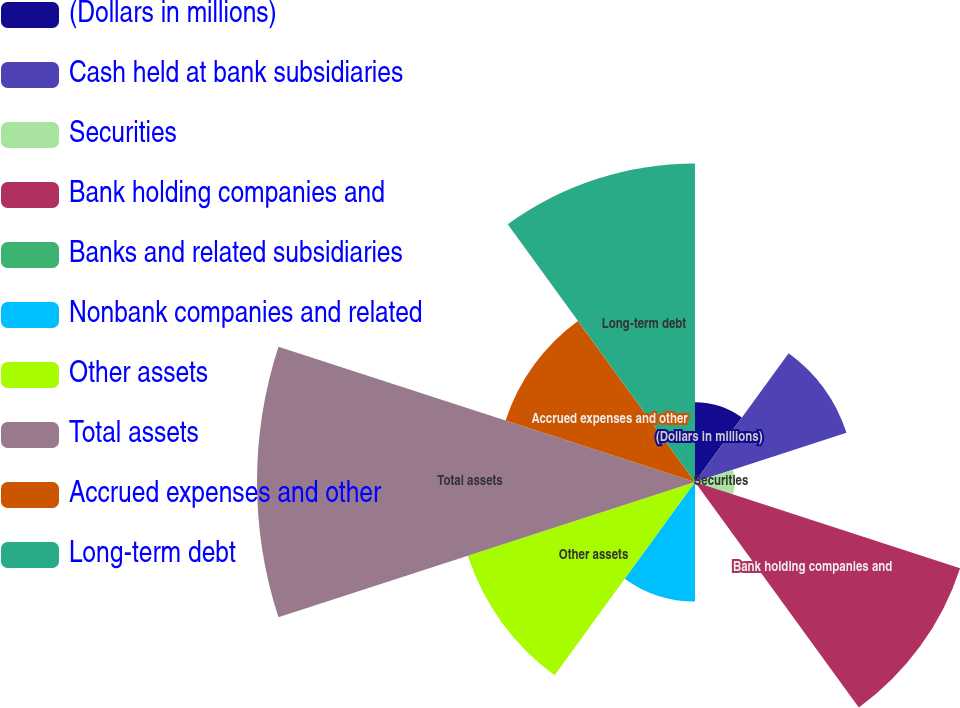Convert chart to OTSL. <chart><loc_0><loc_0><loc_500><loc_500><pie_chart><fcel>(Dollars in millions)<fcel>Cash held at bank subsidiaries<fcel>Securities<fcel>Bank holding companies and<fcel>Banks and related subsidiaries<fcel>Nonbank companies and related<fcel>Other assets<fcel>Total assets<fcel>Accrued expenses and other<fcel>Long-term debt<nl><fcel>4.26%<fcel>8.51%<fcel>2.13%<fcel>14.89%<fcel>0.01%<fcel>6.39%<fcel>12.76%<fcel>23.4%<fcel>10.64%<fcel>17.02%<nl></chart> 